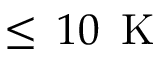<formula> <loc_0><loc_0><loc_500><loc_500>\leq \, 1 0 \, K</formula> 